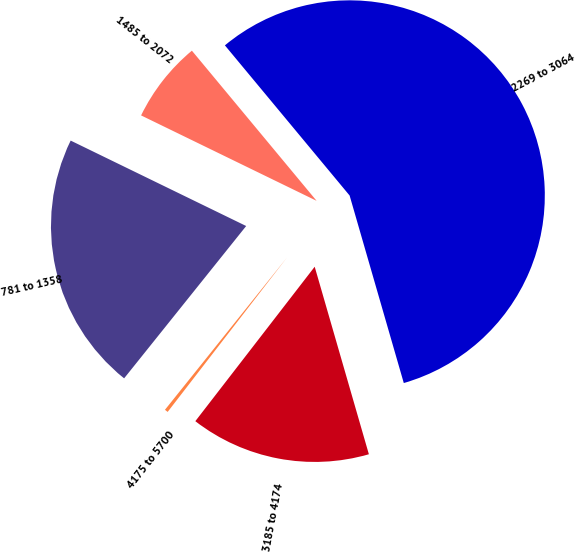<chart> <loc_0><loc_0><loc_500><loc_500><pie_chart><fcel>781 to 1358<fcel>1485 to 2072<fcel>2269 to 3064<fcel>3185 to 4174<fcel>4175 to 5700<nl><fcel>21.46%<fcel>6.76%<fcel>56.56%<fcel>14.95%<fcel>0.28%<nl></chart> 